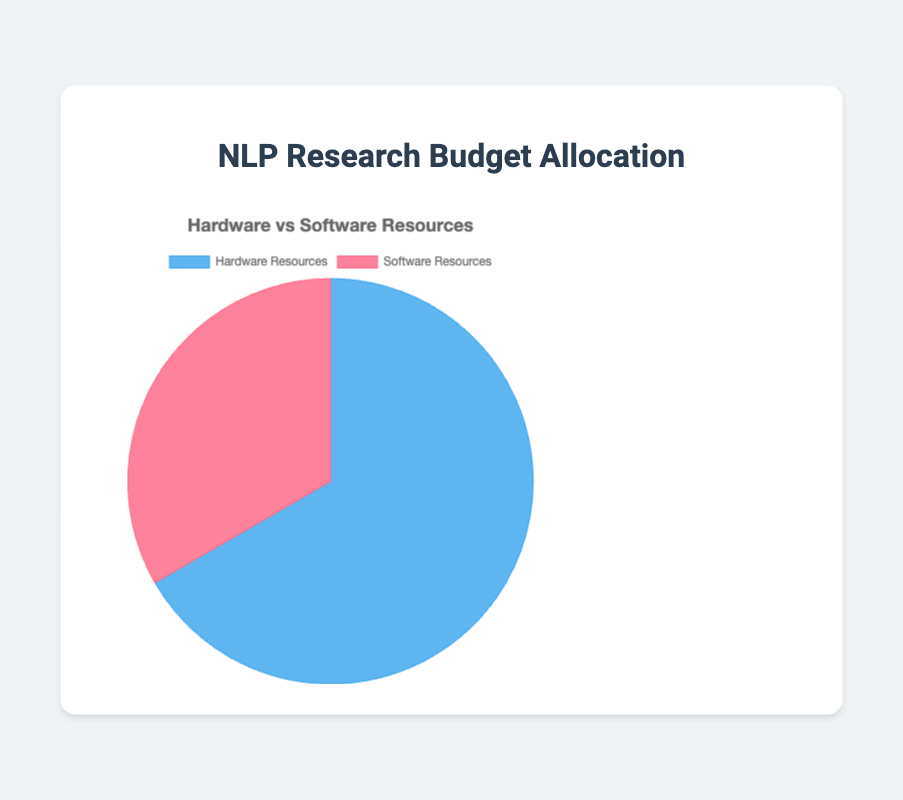Which category has the higher allocated budget, hardware or software resources? From the pie chart, we can see that the slice representing hardware resources is larger than the one for software resources, indicating a higher budget allocation for hardware.
Answer: Hardware Resources How much more budget is allocated to hardware resources compared to software resources? The budget for hardware resources is $60,000, and for software resources, it is $30,000. The difference is $60,000 - $30,000.
Answer: $30,000 What percentage of the total budget is allocated to software resources? The total budget is $60,000 (hardware) + $30,000 (software) = $90,000. The percentage for software resources is ($30,000 / $90,000) * 100.
Answer: 33.33% By how much does the budget for GPUs exceed the combined budget for Licenses for Proprietary Software and Cloud Computing Costs? The budget for GPUs is $30,000. The combined budget for Licenses for Proprietary Software ($15,000) and Cloud Computing Costs ($10,000) is $25,000. The difference is $30,000 - $25,000.
Answer: $5,000 What is the total budget allocated to high-performance computing servers and storage systems? The budget for high-performance computing servers is $20,000, and for storage systems, it is $10,000. The total budget is $20,000 + $10,000.
Answer: $30,000 Which category is represented by the blue color in the pie chart? From the visual information provided, the blue color represents the category with a larger slice. The larger slice in this case is hardware resources.
Answer: Hardware Resources Is the budget allocation for open source toolkit support greater or less than the allocation for storage systems? The budget for open source toolkit support is $5,000, and for storage systems, it is $10,000. Therefore, the allocation for open source toolkit support is less.
Answer: Less What is the average budget allocation for all the categories listed under hardware resources? The budgets for the categories under hardware resources are $30,000 (GPUs), $20,000 (high-performance computing servers), and $10,000 (storage systems). The average is ($30,000 + $20,000 + $10,000) / 3.
Answer: $20,000 If an additional $10,000 were added to the software resources budget, what would be the new percentage allocation for software resources given the current total budget? The new software budget would be $30,000 + $10,000 = $40,000. The new total budget would be $90,000 + $10,000 = $100,000. The percentage for software resources would be ($40,000 / $100,000) * 100.
Answer: 40% 